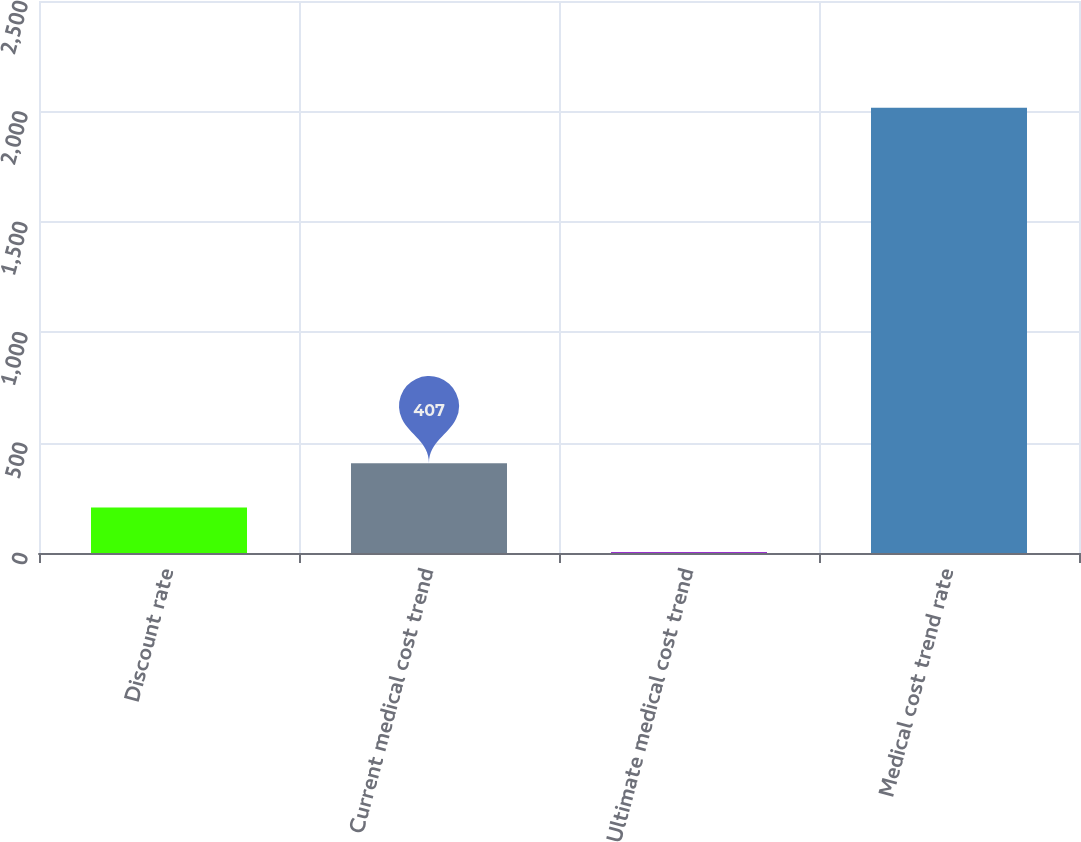<chart> <loc_0><loc_0><loc_500><loc_500><bar_chart><fcel>Discount rate<fcel>Current medical cost trend<fcel>Ultimate medical cost trend<fcel>Medical cost trend rate<nl><fcel>205.88<fcel>407<fcel>4.75<fcel>2016<nl></chart> 